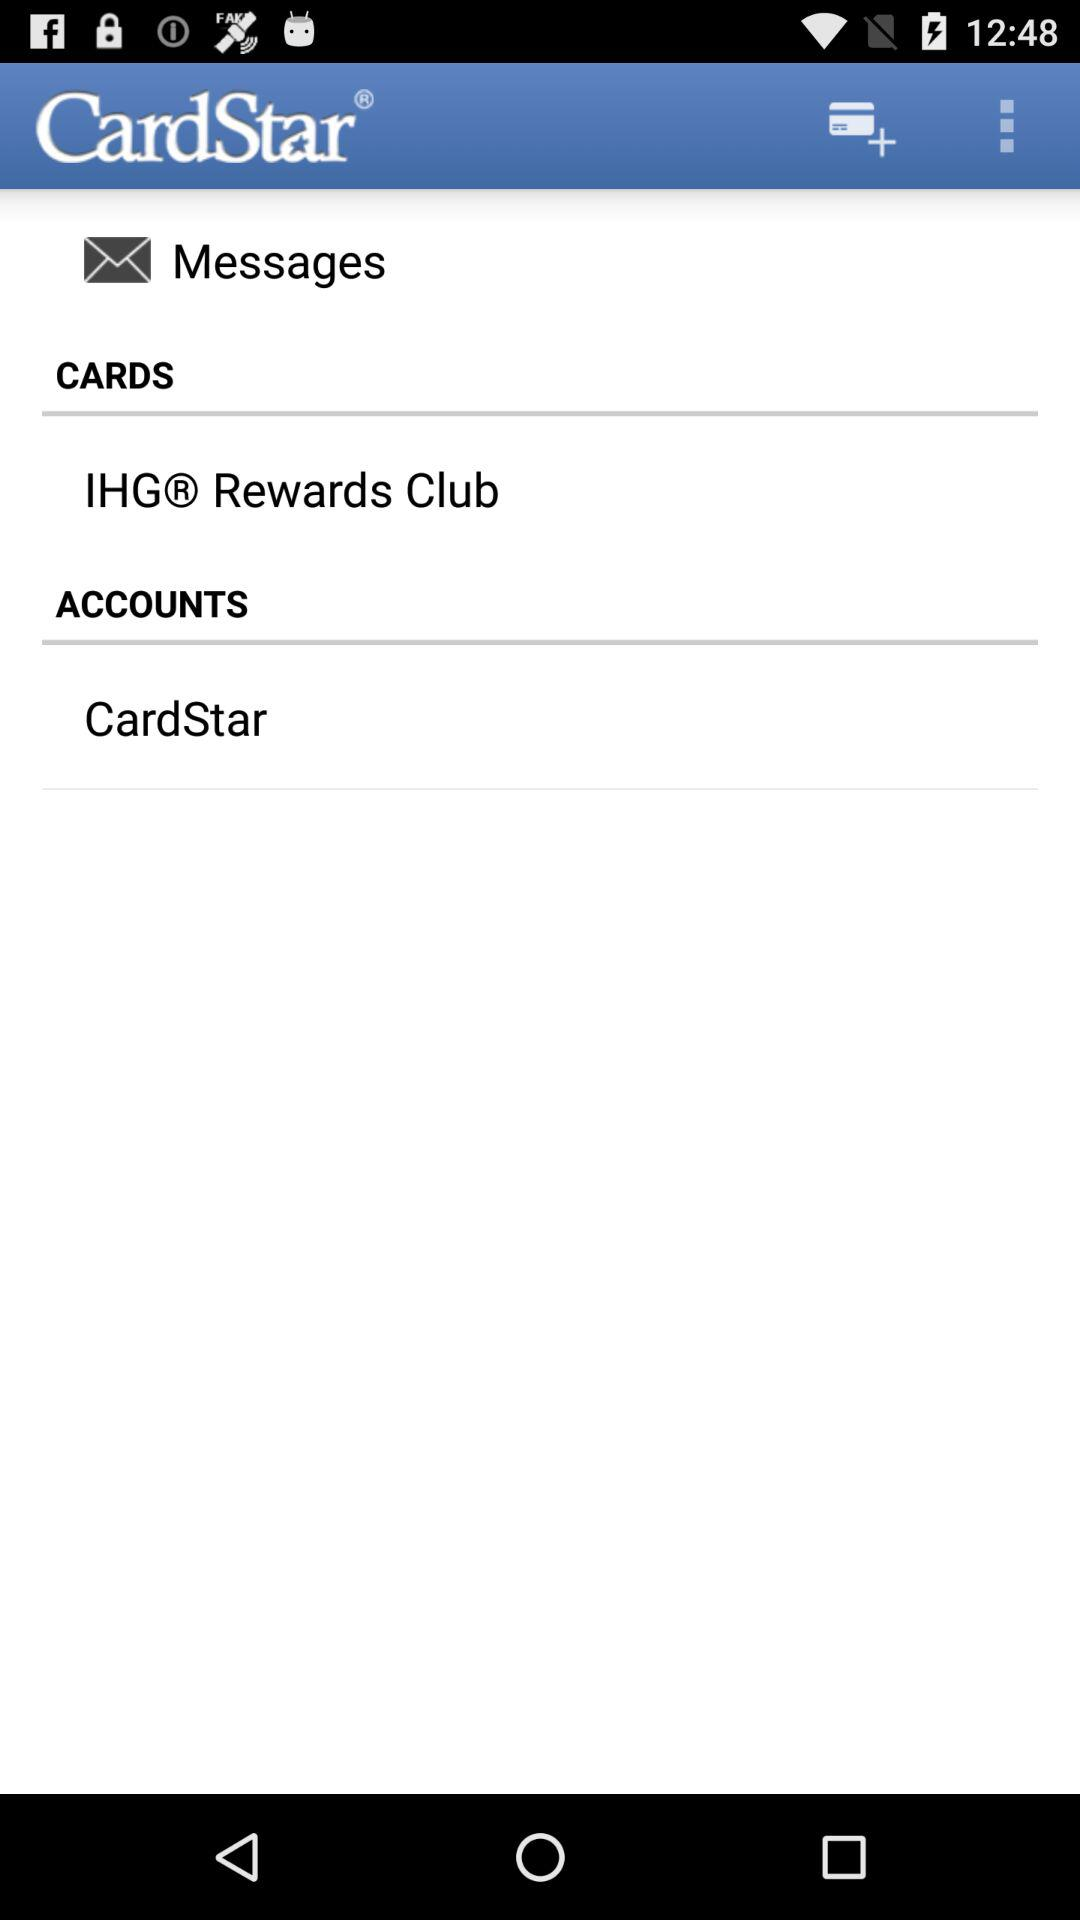Which card is selected in the Cards option?
When the provided information is insufficient, respond with <no answer>. <no answer> 